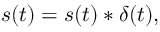<formula> <loc_0><loc_0><loc_500><loc_500>s ( t ) = s ( t ) * \delta ( t ) ,</formula> 